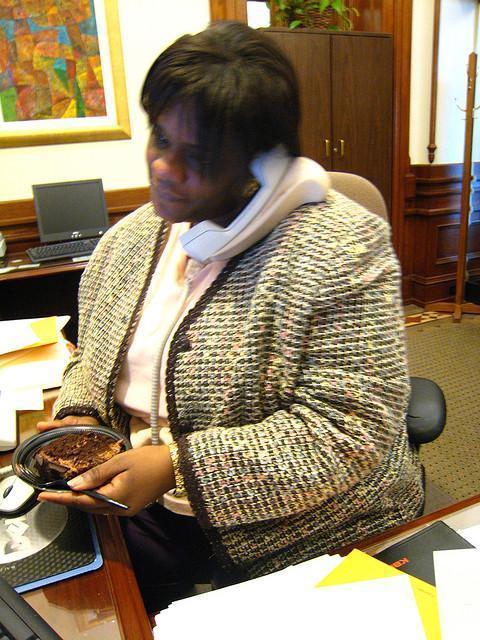How many tvs are there?
Give a very brief answer. 1. How many bowls are on the table?
Give a very brief answer. 0. 